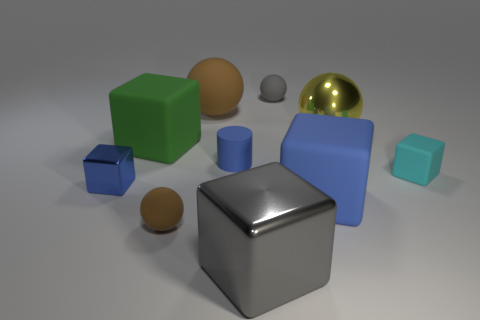There is a tiny metal thing that is the same color as the matte cylinder; what is its shape?
Provide a short and direct response. Cube. There is a matte cube that is the same color as the tiny metallic thing; what is its size?
Keep it short and to the point. Large. The other brown matte thing that is the same shape as the small brown object is what size?
Provide a succinct answer. Large. Does the large green thing have the same shape as the tiny blue rubber object?
Offer a terse response. No. There is a gray thing behind the metallic thing that is behind the small blue rubber thing; how big is it?
Keep it short and to the point. Small. The small rubber thing that is the same shape as the gray shiny object is what color?
Give a very brief answer. Cyan. How many big things have the same color as the matte cylinder?
Ensure brevity in your answer.  1. The yellow shiny thing is what size?
Offer a terse response. Large. Is the metallic ball the same size as the gray matte thing?
Your response must be concise. No. There is a thing that is to the right of the small blue cylinder and in front of the large blue matte thing; what color is it?
Provide a short and direct response. Gray. 